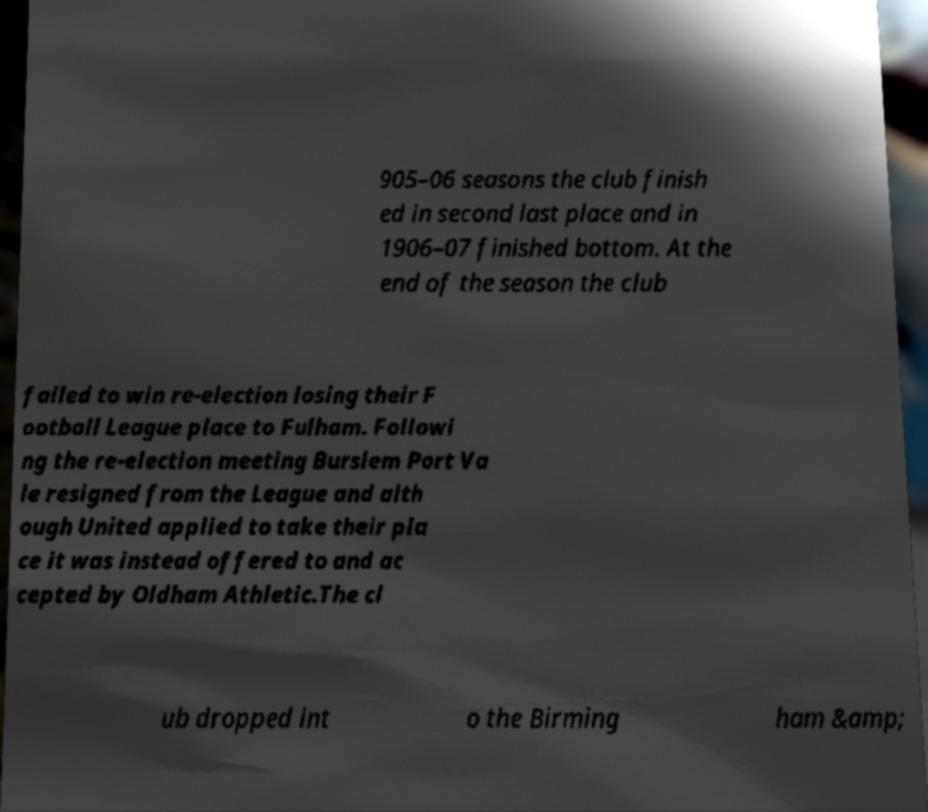Could you extract and type out the text from this image? 905–06 seasons the club finish ed in second last place and in 1906–07 finished bottom. At the end of the season the club failed to win re-election losing their F ootball League place to Fulham. Followi ng the re-election meeting Burslem Port Va le resigned from the League and alth ough United applied to take their pla ce it was instead offered to and ac cepted by Oldham Athletic.The cl ub dropped int o the Birming ham &amp; 